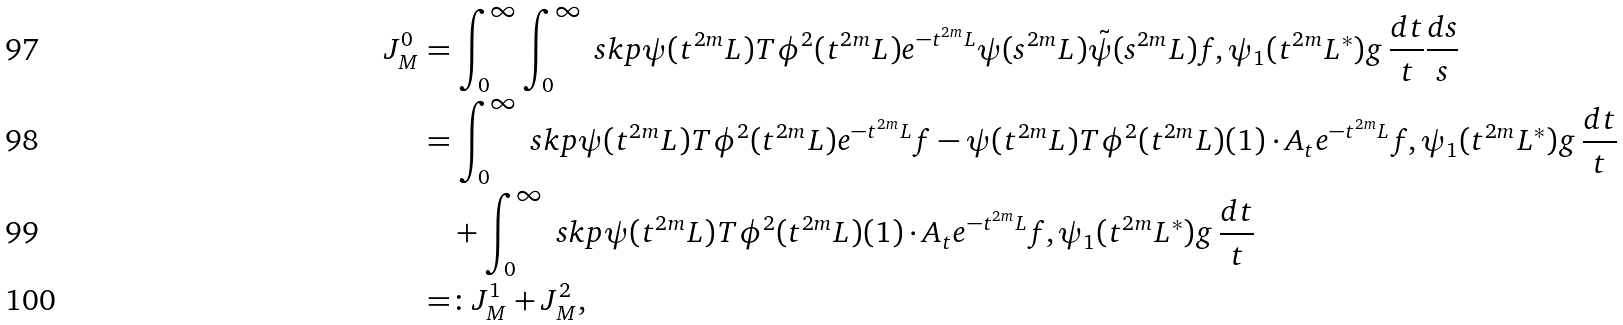<formula> <loc_0><loc_0><loc_500><loc_500>J _ { M } ^ { 0 } & = \int _ { 0 } ^ { \infty } \int _ { 0 } ^ { \infty } \ s k p { \psi ( t ^ { 2 m } L ) T \phi ^ { 2 } ( t ^ { 2 m } L ) e ^ { - t ^ { 2 m } L } \psi ( s ^ { 2 m } L ) \tilde { \psi } ( s ^ { 2 m } L ) f , \psi _ { 1 } ( t ^ { 2 m } L ^ { \ast } ) g } \, \frac { d t } { t } \frac { d s } { s } \\ & = \int _ { 0 } ^ { \infty } \ s k p { \psi ( t ^ { 2 m } L ) T \phi ^ { 2 } ( t ^ { 2 m } L ) e ^ { - t ^ { 2 m } L } f - \psi ( t ^ { 2 m } L ) T \phi ^ { 2 } ( t ^ { 2 m } L ) ( 1 ) \cdot A _ { t } e ^ { - t ^ { 2 m } L } f , \psi _ { 1 } ( t ^ { 2 m } L ^ { \ast } ) g } \, \frac { d t } { t } \\ & \quad + \int _ { 0 } ^ { \infty } \ s k p { \psi ( t ^ { 2 m } L ) T \phi ^ { 2 } ( t ^ { 2 m } L ) ( 1 ) \cdot A _ { t } e ^ { - t ^ { 2 m } L } f , \psi _ { 1 } ( t ^ { 2 m } L ^ { \ast } ) g } \, \frac { d t } { t } \\ & = \colon J _ { M } ^ { 1 } + J _ { M } ^ { 2 } ,</formula> 